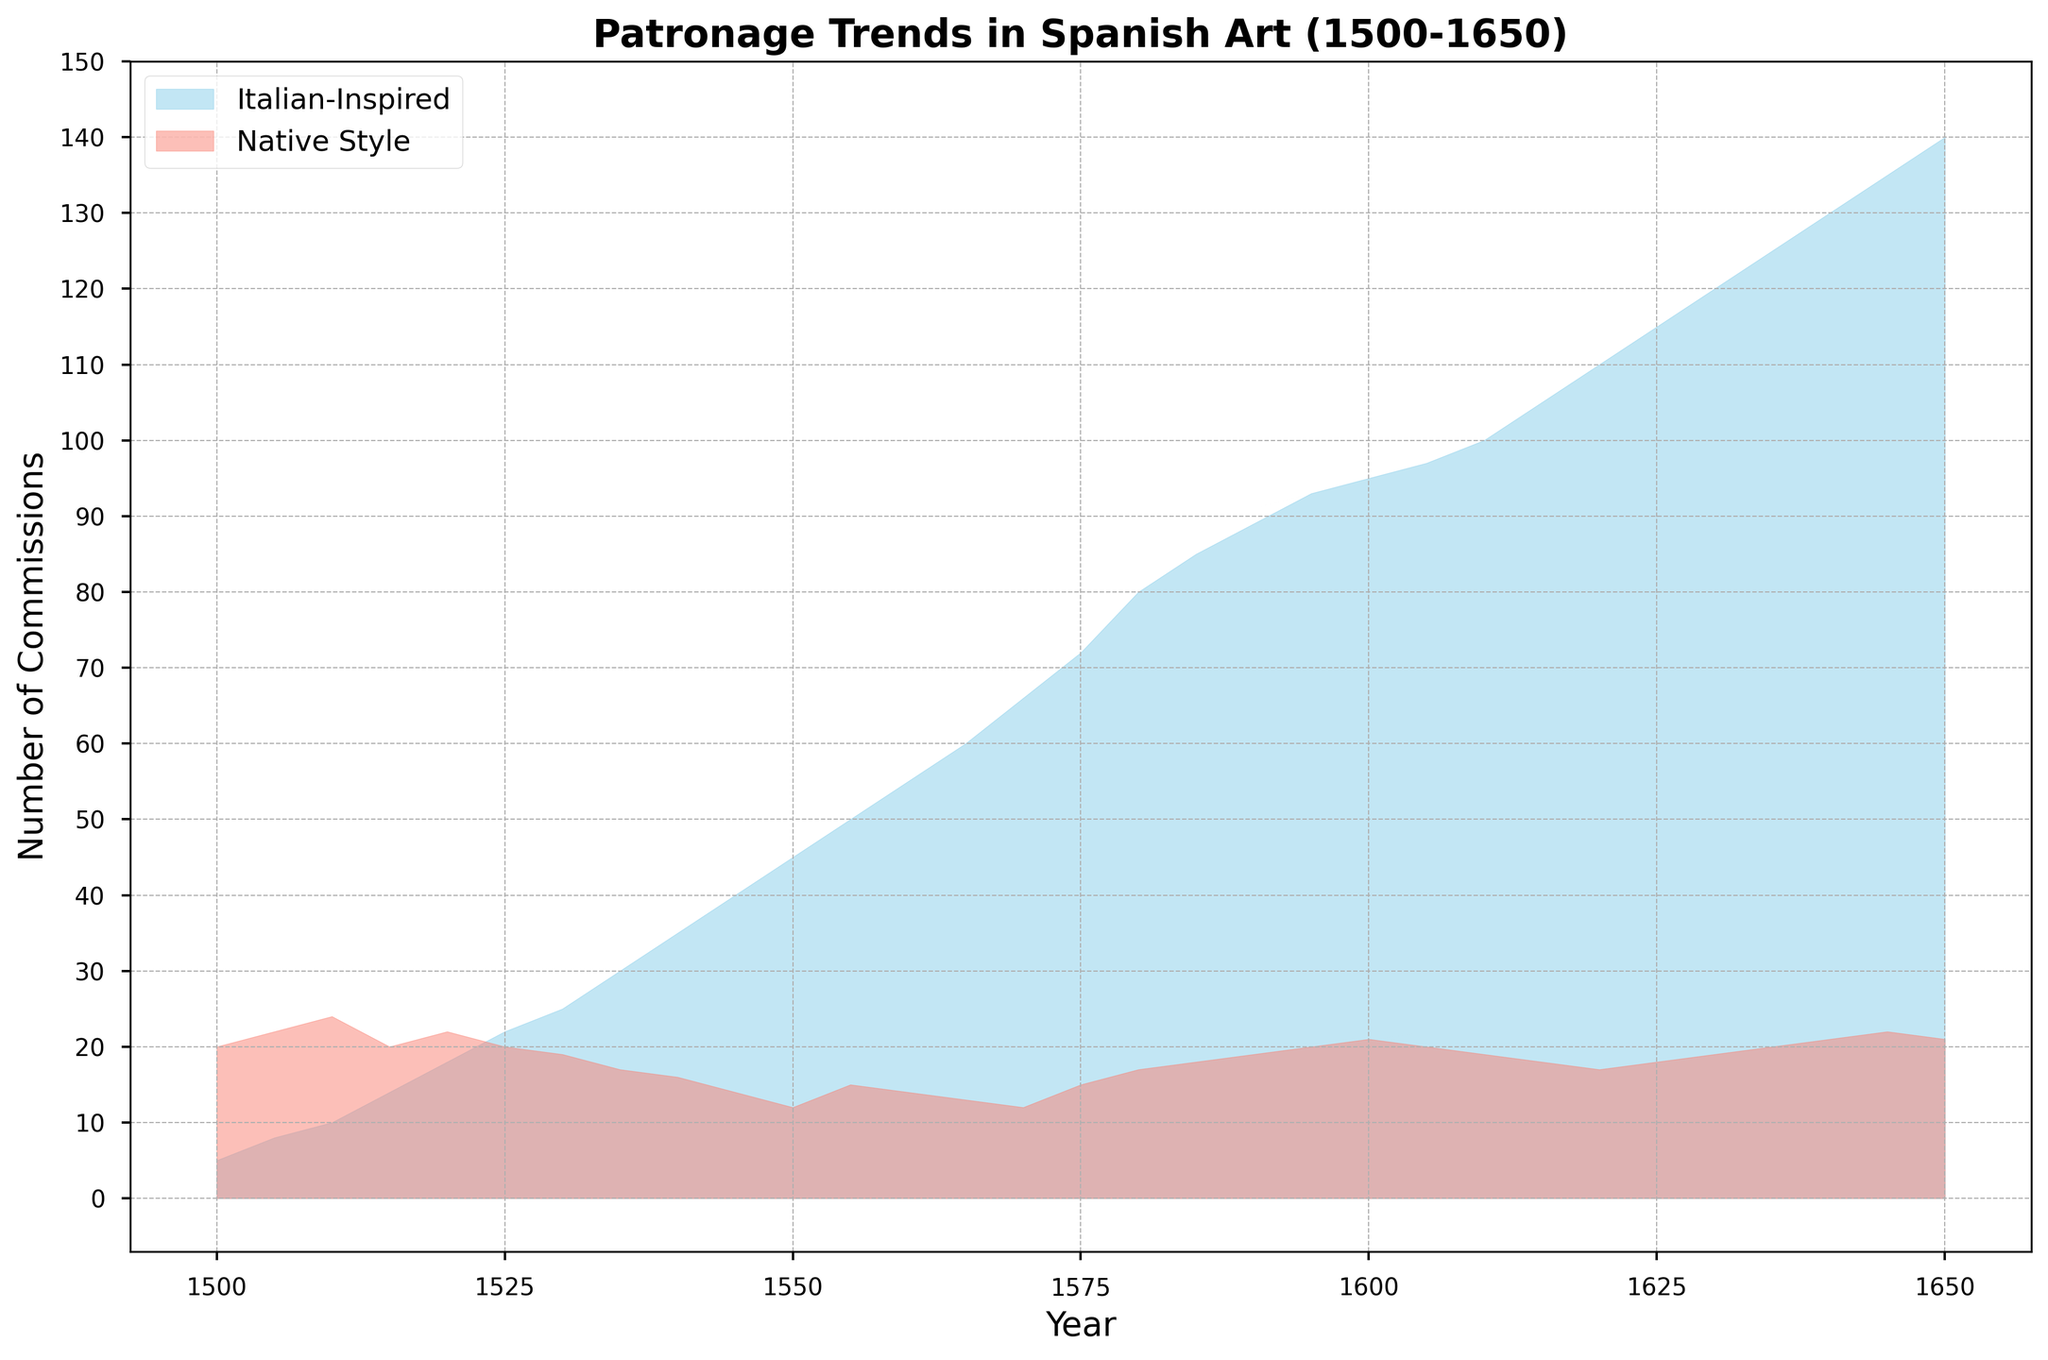When do Italian-Inspired Commissions first surpass Native Style Commissions? To answer, identify the year where the Italian-Inspired Commissions visually exceed the height of the Native Style Commissions. This first occurs around the year 1530, where Italian-Inspired Commissions reach 25 and Native Style Commissions are 19.
Answer: 1530 What is the total number of Italian-Inspired Commissions between 1500 to 1550? Sum the Italian-Inspired Commissions values from year 1500 to 1550: 5 + 8 + 10 + 14 + 18 + 22 + 25 + 30 + 35 + 40 + 45 = 252
Answer: 252 What is the highest single-year value for Native Style Commissions, and in what year does it occur? Look for the peak in Native Style Commissions over the years. The highest value is 22, seen in multiple years (1500, 1505, 1520, 1620, 1645). The first occurrence is in 1500.
Answer: 22, 1500 How does the number of Italian-Inspired Commissions in 1600 compare to that in 1650? Compare the Italian-Inspired Commissions in the years 1600 and 1650: 95 commissions in 1600, 140 in 1650. Therefore, 1650 is greater.
Answer: 1650 Calculate the average number of Native Style Commissions from 1510 to 1550. The values are 24, 20, 22, 20, 19, 17, 16, 14, and 12. Adding these: 24 + 20 + 22 + 20 + 19 + 17 + 16 + 14 + 12 = 144. There are 9 values, so, the average is 144 / 9 = 16
Answer: 16 Between 1570 and 1600, describe the trend for Italian-Inspired Commissions. From 1570 (66 commissions) to 1600 (95 commissions), the number of Italian-Inspired Commissions generally increases.
Answer: Increasing What is the difference between the Italian-Inspired and Native Style Commissions in 1550? For the year 1550, subtract Native Style Commissions from Italian-Inspired Commissions: 45 - 12 = 33
Answer: 33 Identify the years when Native Style Commissions equal 15. Locate the years where the Native Style Commissions are 15 by observing the graph. The values are 1505, 1515, 1555, and 1575.
Answer: 1505, 1515, 1555, 1575 How does the area of Italian-Inspired Commissions shift over time compared to Native Style Commissions? Visually from the plot, the area under the Italian-Inspired Commissions curve consistently grows and eventually surpasses the declining Native Style Commissions area, indicating increasing interest in Italian styles over time.
Answer: Increasing relative to Native Styles 